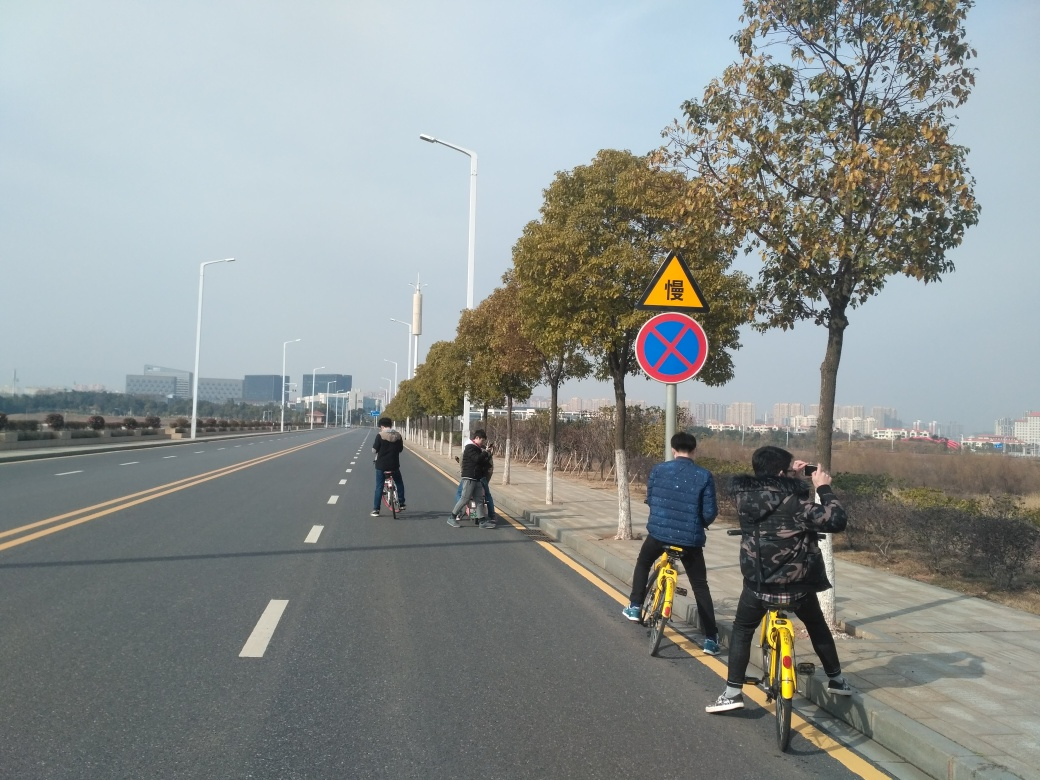Is there any blurriness in the image? After carefully examining the image, I can confirm that it is sharp and clear. There is no blurriness that affects the visibility of the scene, which includes people riding bicycles and a clear view of the road signs and surroundings. 